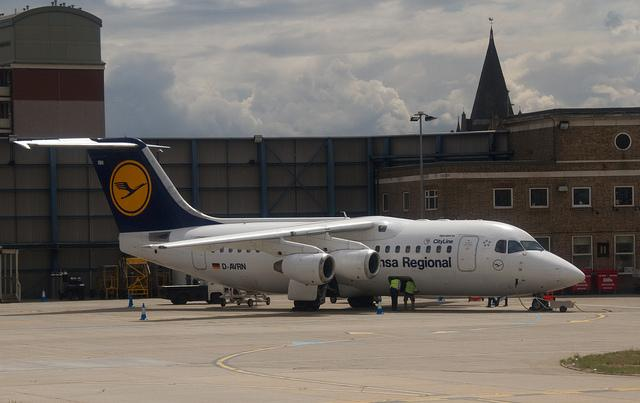What company owns this vehicle? lufthansa 